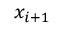Convert formula to latex. <formula><loc_0><loc_0><loc_500><loc_500>x _ { i + 1 }</formula> 